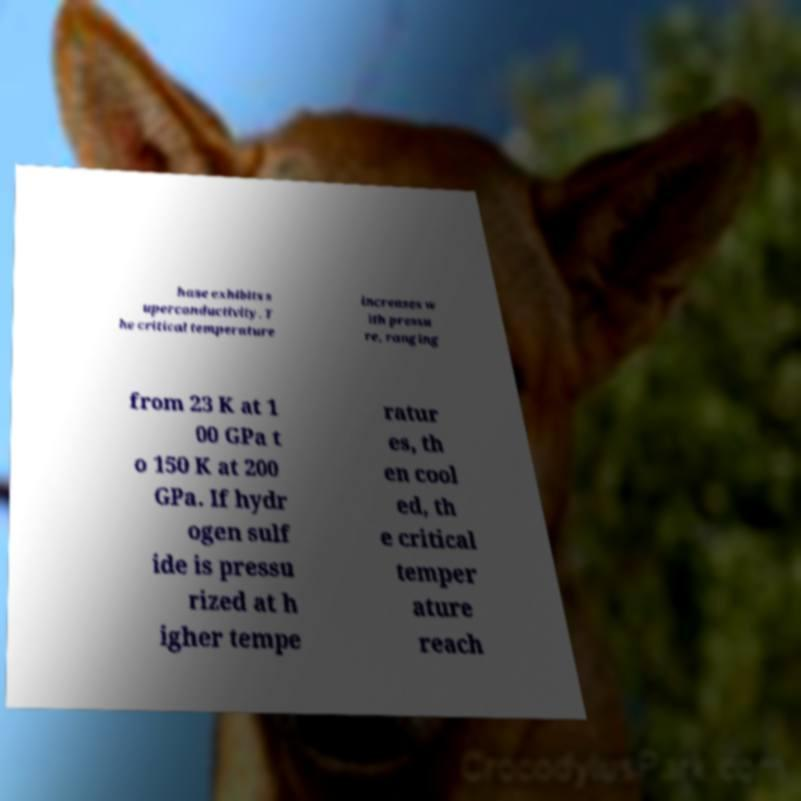What messages or text are displayed in this image? I need them in a readable, typed format. hase exhibits s uperconductivity. T he critical temperature increases w ith pressu re, ranging from 23 K at 1 00 GPa t o 150 K at 200 GPa. If hydr ogen sulf ide is pressu rized at h igher tempe ratur es, th en cool ed, th e critical temper ature reach 